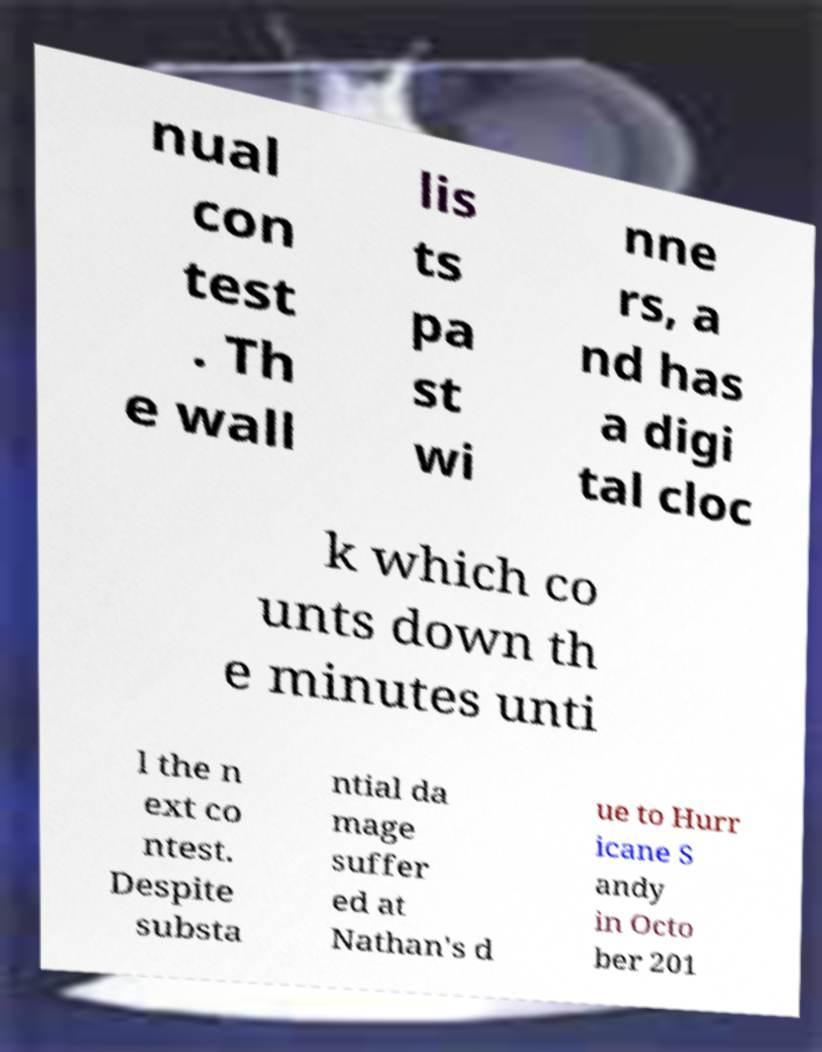Please read and relay the text visible in this image. What does it say? nual con test . Th e wall lis ts pa st wi nne rs, a nd has a digi tal cloc k which co unts down th e minutes unti l the n ext co ntest. Despite substa ntial da mage suffer ed at Nathan's d ue to Hurr icane S andy in Octo ber 201 